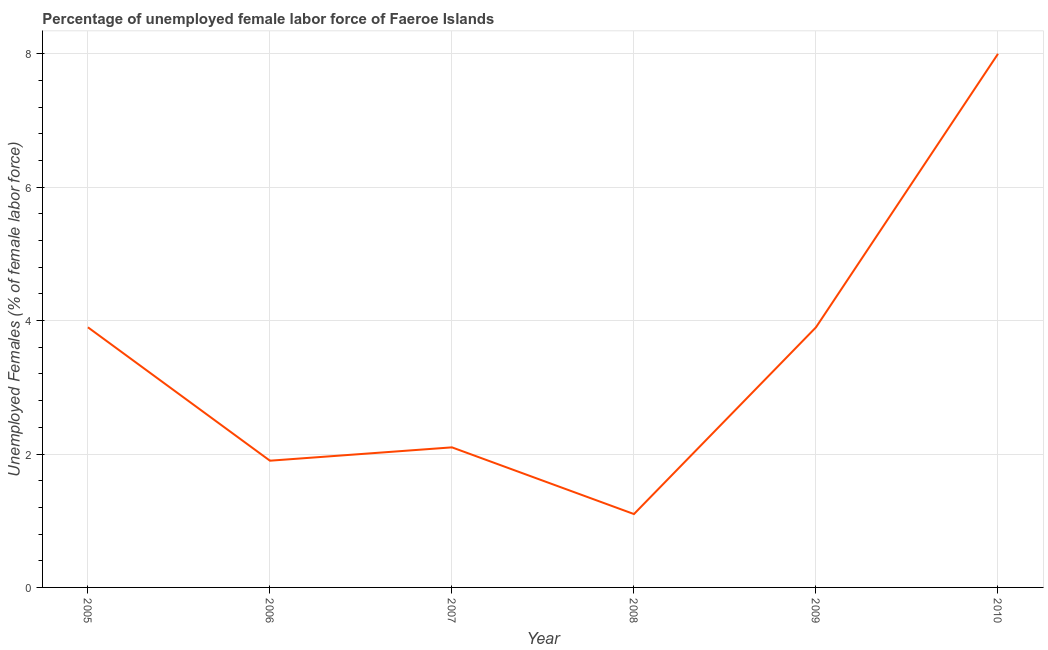What is the total unemployed female labour force in 2010?
Your answer should be compact. 8. Across all years, what is the maximum total unemployed female labour force?
Make the answer very short. 8. Across all years, what is the minimum total unemployed female labour force?
Your response must be concise. 1.1. What is the sum of the total unemployed female labour force?
Your response must be concise. 20.9. What is the difference between the total unemployed female labour force in 2008 and 2010?
Provide a succinct answer. -6.9. What is the average total unemployed female labour force per year?
Provide a succinct answer. 3.48. Do a majority of the years between 2006 and 2005 (inclusive) have total unemployed female labour force greater than 0.8 %?
Keep it short and to the point. No. What is the ratio of the total unemployed female labour force in 2006 to that in 2010?
Give a very brief answer. 0.24. What is the difference between the highest and the second highest total unemployed female labour force?
Your answer should be compact. 4.1. Is the sum of the total unemployed female labour force in 2006 and 2008 greater than the maximum total unemployed female labour force across all years?
Offer a very short reply. No. What is the difference between the highest and the lowest total unemployed female labour force?
Provide a short and direct response. 6.9. How many years are there in the graph?
Ensure brevity in your answer.  6. What is the title of the graph?
Your answer should be very brief. Percentage of unemployed female labor force of Faeroe Islands. What is the label or title of the X-axis?
Offer a very short reply. Year. What is the label or title of the Y-axis?
Offer a terse response. Unemployed Females (% of female labor force). What is the Unemployed Females (% of female labor force) of 2005?
Offer a terse response. 3.9. What is the Unemployed Females (% of female labor force) of 2006?
Ensure brevity in your answer.  1.9. What is the Unemployed Females (% of female labor force) of 2007?
Your answer should be very brief. 2.1. What is the Unemployed Females (% of female labor force) of 2008?
Your answer should be very brief. 1.1. What is the Unemployed Females (% of female labor force) of 2009?
Keep it short and to the point. 3.9. What is the Unemployed Females (% of female labor force) of 2010?
Your answer should be compact. 8. What is the difference between the Unemployed Females (% of female labor force) in 2005 and 2006?
Offer a very short reply. 2. What is the difference between the Unemployed Females (% of female labor force) in 2005 and 2008?
Ensure brevity in your answer.  2.8. What is the difference between the Unemployed Females (% of female labor force) in 2006 and 2007?
Ensure brevity in your answer.  -0.2. What is the difference between the Unemployed Females (% of female labor force) in 2006 and 2008?
Keep it short and to the point. 0.8. What is the difference between the Unemployed Females (% of female labor force) in 2006 and 2009?
Your response must be concise. -2. What is the difference between the Unemployed Females (% of female labor force) in 2006 and 2010?
Offer a very short reply. -6.1. What is the difference between the Unemployed Females (% of female labor force) in 2007 and 2009?
Your answer should be compact. -1.8. What is the difference between the Unemployed Females (% of female labor force) in 2008 and 2010?
Your answer should be very brief. -6.9. What is the difference between the Unemployed Females (% of female labor force) in 2009 and 2010?
Your response must be concise. -4.1. What is the ratio of the Unemployed Females (% of female labor force) in 2005 to that in 2006?
Your answer should be compact. 2.05. What is the ratio of the Unemployed Females (% of female labor force) in 2005 to that in 2007?
Make the answer very short. 1.86. What is the ratio of the Unemployed Females (% of female labor force) in 2005 to that in 2008?
Provide a succinct answer. 3.54. What is the ratio of the Unemployed Females (% of female labor force) in 2005 to that in 2009?
Give a very brief answer. 1. What is the ratio of the Unemployed Females (% of female labor force) in 2005 to that in 2010?
Your response must be concise. 0.49. What is the ratio of the Unemployed Females (% of female labor force) in 2006 to that in 2007?
Your response must be concise. 0.91. What is the ratio of the Unemployed Females (% of female labor force) in 2006 to that in 2008?
Offer a very short reply. 1.73. What is the ratio of the Unemployed Females (% of female labor force) in 2006 to that in 2009?
Provide a succinct answer. 0.49. What is the ratio of the Unemployed Females (% of female labor force) in 2006 to that in 2010?
Your answer should be very brief. 0.24. What is the ratio of the Unemployed Females (% of female labor force) in 2007 to that in 2008?
Your response must be concise. 1.91. What is the ratio of the Unemployed Females (% of female labor force) in 2007 to that in 2009?
Provide a succinct answer. 0.54. What is the ratio of the Unemployed Females (% of female labor force) in 2007 to that in 2010?
Your response must be concise. 0.26. What is the ratio of the Unemployed Females (% of female labor force) in 2008 to that in 2009?
Offer a very short reply. 0.28. What is the ratio of the Unemployed Females (% of female labor force) in 2008 to that in 2010?
Your response must be concise. 0.14. What is the ratio of the Unemployed Females (% of female labor force) in 2009 to that in 2010?
Your answer should be very brief. 0.49. 